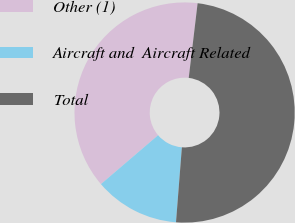<chart> <loc_0><loc_0><loc_500><loc_500><pie_chart><fcel>Other (1)<fcel>Aircraft and  Aircraft Related<fcel>Total<nl><fcel>38.15%<fcel>12.49%<fcel>49.36%<nl></chart> 